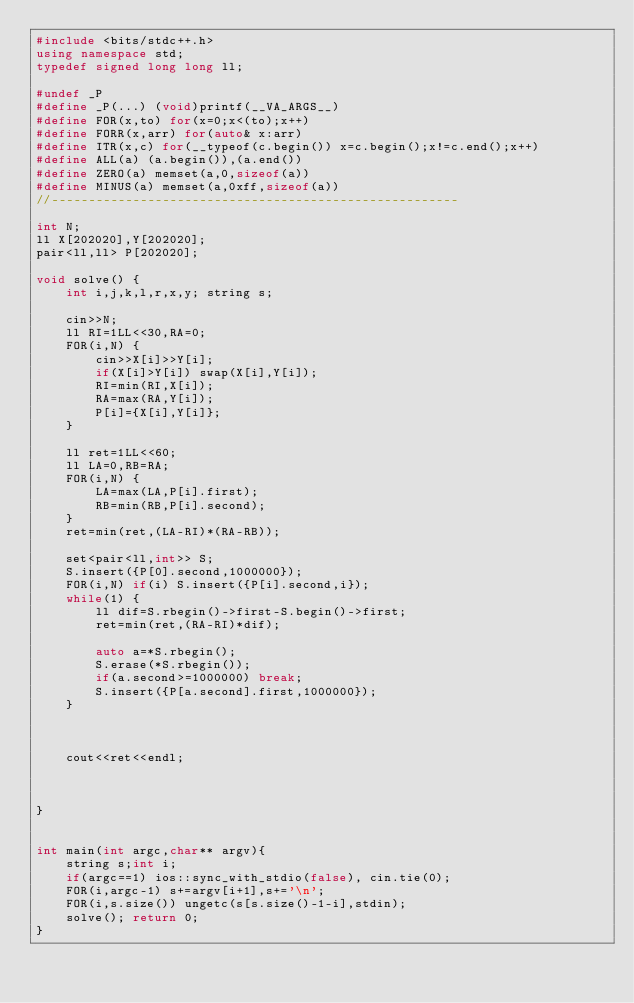<code> <loc_0><loc_0><loc_500><loc_500><_C++_>#include <bits/stdc++.h>
using namespace std;
typedef signed long long ll;

#undef _P
#define _P(...) (void)printf(__VA_ARGS__)
#define FOR(x,to) for(x=0;x<(to);x++)
#define FORR(x,arr) for(auto& x:arr)
#define ITR(x,c) for(__typeof(c.begin()) x=c.begin();x!=c.end();x++)
#define ALL(a) (a.begin()),(a.end())
#define ZERO(a) memset(a,0,sizeof(a))
#define MINUS(a) memset(a,0xff,sizeof(a))
//-------------------------------------------------------

int N;
ll X[202020],Y[202020];
pair<ll,ll> P[202020];

void solve() {
	int i,j,k,l,r,x,y; string s;
	
	cin>>N;
	ll RI=1LL<<30,RA=0;
	FOR(i,N) {
		cin>>X[i]>>Y[i];
		if(X[i]>Y[i]) swap(X[i],Y[i]);
		RI=min(RI,X[i]);
		RA=max(RA,Y[i]);
		P[i]={X[i],Y[i]};
	}
	
	ll ret=1LL<<60;
	ll LA=0,RB=RA;
	FOR(i,N) {
		LA=max(LA,P[i].first);
		RB=min(RB,P[i].second);
	}
	ret=min(ret,(LA-RI)*(RA-RB));
	
	set<pair<ll,int>> S;
	S.insert({P[0].second,1000000});
	FOR(i,N) if(i) S.insert({P[i].second,i});
	while(1) {
		ll dif=S.rbegin()->first-S.begin()->first;
		ret=min(ret,(RA-RI)*dif);
		
		auto a=*S.rbegin();
		S.erase(*S.rbegin());
		if(a.second>=1000000) break;
		S.insert({P[a.second].first,1000000});
	}
	
	
	
	cout<<ret<<endl;
	
	
	
}


int main(int argc,char** argv){
	string s;int i;
	if(argc==1) ios::sync_with_stdio(false), cin.tie(0);
	FOR(i,argc-1) s+=argv[i+1],s+='\n';
	FOR(i,s.size()) ungetc(s[s.size()-1-i],stdin);
	solve(); return 0;
}
</code> 